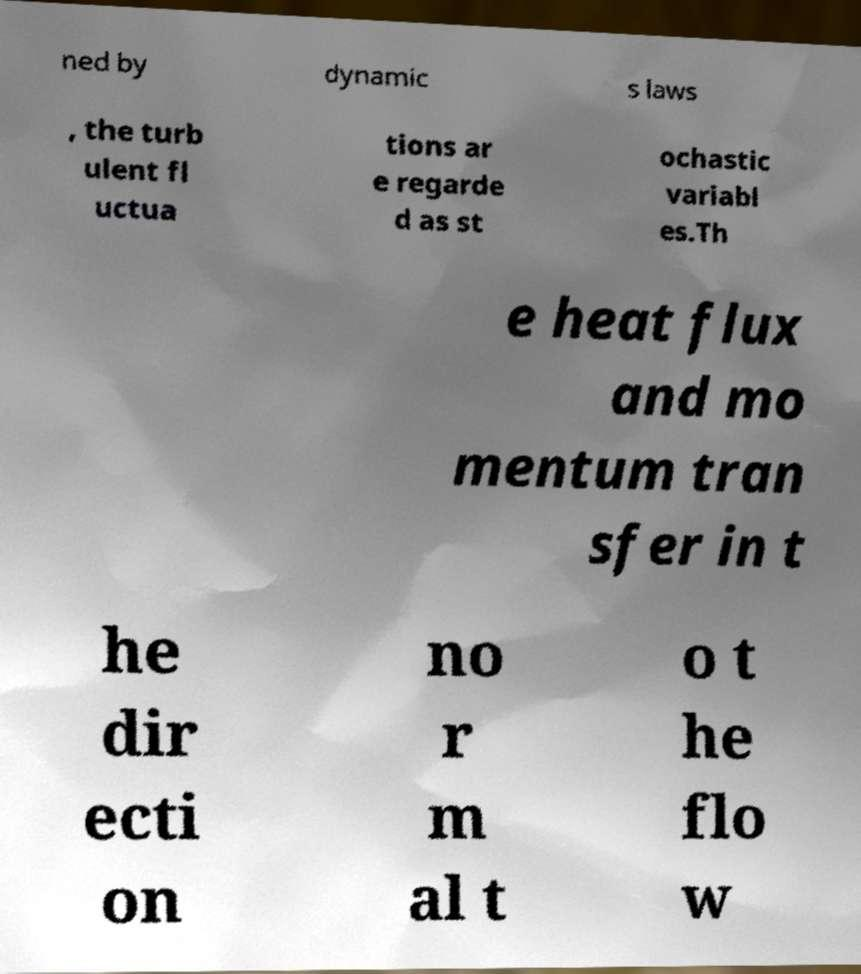Can you accurately transcribe the text from the provided image for me? ned by dynamic s laws , the turb ulent fl uctua tions ar e regarde d as st ochastic variabl es.Th e heat flux and mo mentum tran sfer in t he dir ecti on no r m al t o t he flo w 